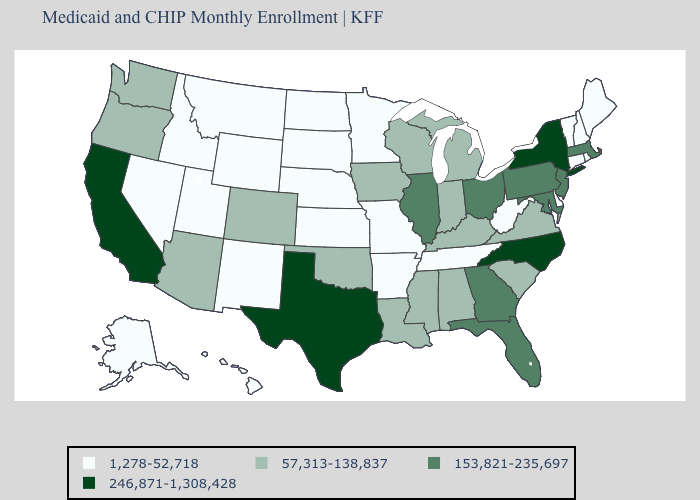Does the map have missing data?
Keep it brief. No. What is the lowest value in states that border Minnesota?
Short answer required. 1,278-52,718. Among the states that border Georgia , which have the highest value?
Give a very brief answer. North Carolina. What is the value of North Dakota?
Answer briefly. 1,278-52,718. Name the states that have a value in the range 1,278-52,718?
Quick response, please. Alaska, Arkansas, Connecticut, Delaware, Hawaii, Idaho, Kansas, Maine, Minnesota, Missouri, Montana, Nebraska, Nevada, New Hampshire, New Mexico, North Dakota, Rhode Island, South Dakota, Tennessee, Utah, Vermont, West Virginia, Wyoming. What is the value of Virginia?
Write a very short answer. 57,313-138,837. What is the value of Georgia?
Short answer required. 153,821-235,697. Name the states that have a value in the range 246,871-1,308,428?
Quick response, please. California, New York, North Carolina, Texas. Does North Carolina have the lowest value in the South?
Keep it brief. No. What is the value of North Dakota?
Keep it brief. 1,278-52,718. What is the value of Oklahoma?
Quick response, please. 57,313-138,837. Name the states that have a value in the range 57,313-138,837?
Give a very brief answer. Alabama, Arizona, Colorado, Indiana, Iowa, Kentucky, Louisiana, Michigan, Mississippi, Oklahoma, Oregon, South Carolina, Virginia, Washington, Wisconsin. What is the lowest value in the West?
Quick response, please. 1,278-52,718. Name the states that have a value in the range 1,278-52,718?
Concise answer only. Alaska, Arkansas, Connecticut, Delaware, Hawaii, Idaho, Kansas, Maine, Minnesota, Missouri, Montana, Nebraska, Nevada, New Hampshire, New Mexico, North Dakota, Rhode Island, South Dakota, Tennessee, Utah, Vermont, West Virginia, Wyoming. What is the lowest value in the USA?
Give a very brief answer. 1,278-52,718. 